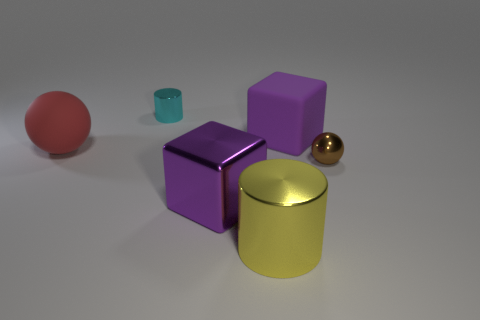Add 2 small brown matte cylinders. How many objects exist? 8 Subtract all balls. How many objects are left? 4 Add 2 gray matte cubes. How many gray matte cubes exist? 2 Subtract 0 cyan balls. How many objects are left? 6 Subtract all large gray shiny objects. Subtract all purple cubes. How many objects are left? 4 Add 5 blocks. How many blocks are left? 7 